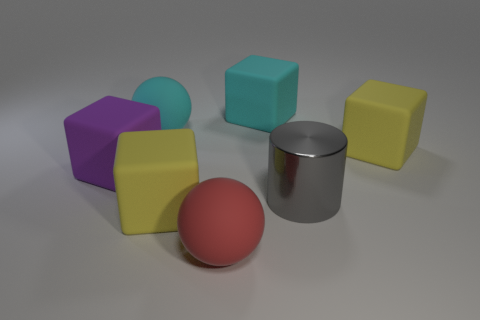Subtract all purple blocks. How many blocks are left? 3 Subtract all red blocks. Subtract all blue balls. How many blocks are left? 4 Add 2 red rubber spheres. How many objects exist? 9 Subtract all cubes. How many objects are left? 3 Subtract 0 blue cylinders. How many objects are left? 7 Subtract all big rubber balls. Subtract all purple rubber cubes. How many objects are left? 4 Add 4 cylinders. How many cylinders are left? 5 Add 7 big shiny cylinders. How many big shiny cylinders exist? 8 